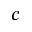<formula> <loc_0><loc_0><loc_500><loc_500>^ { c }</formula> 